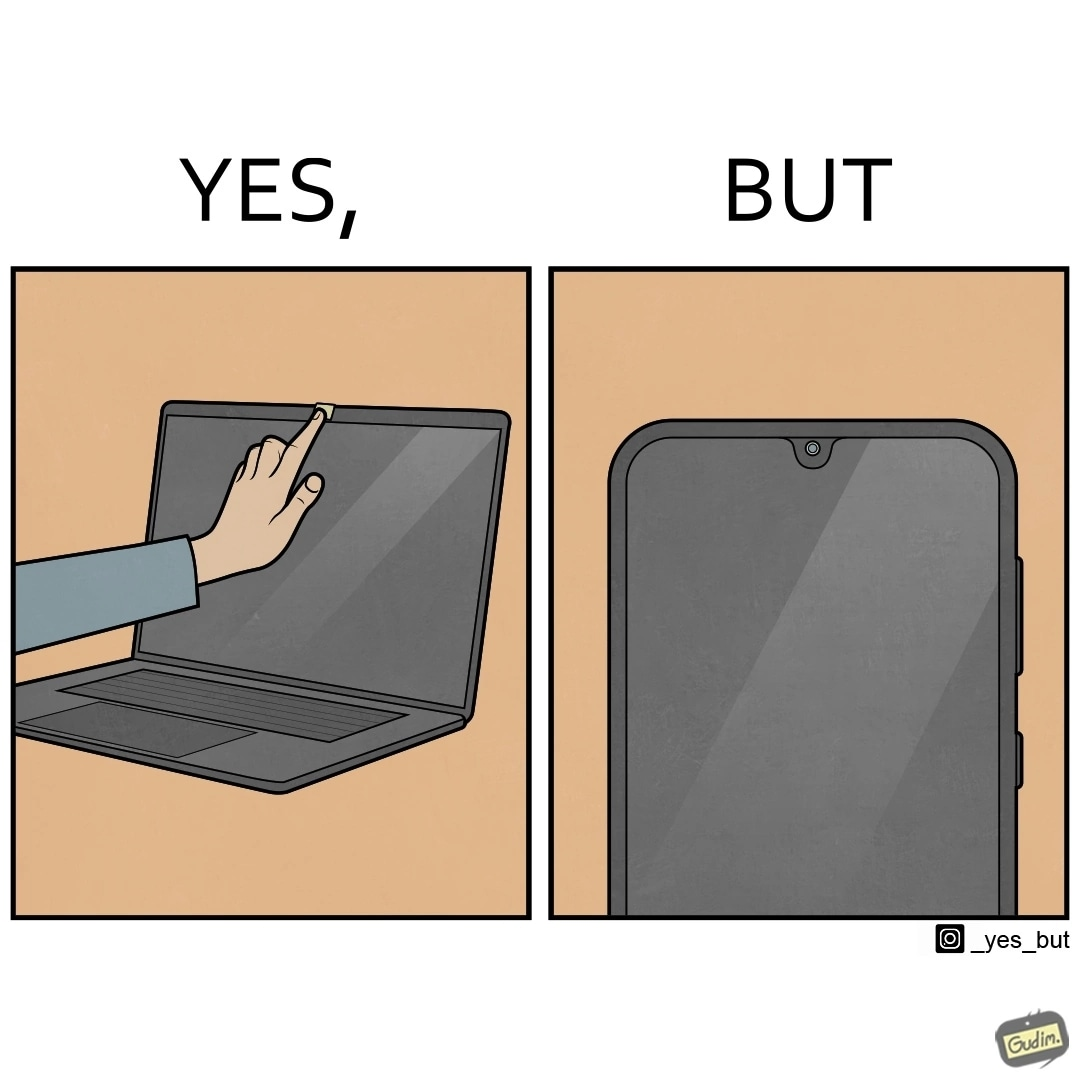What does this image depict? The image is ironic, because the person is seen as applying tape over laptop's camera over some privacy concerns but on the other hand he/she carries the phone without covering its camera 